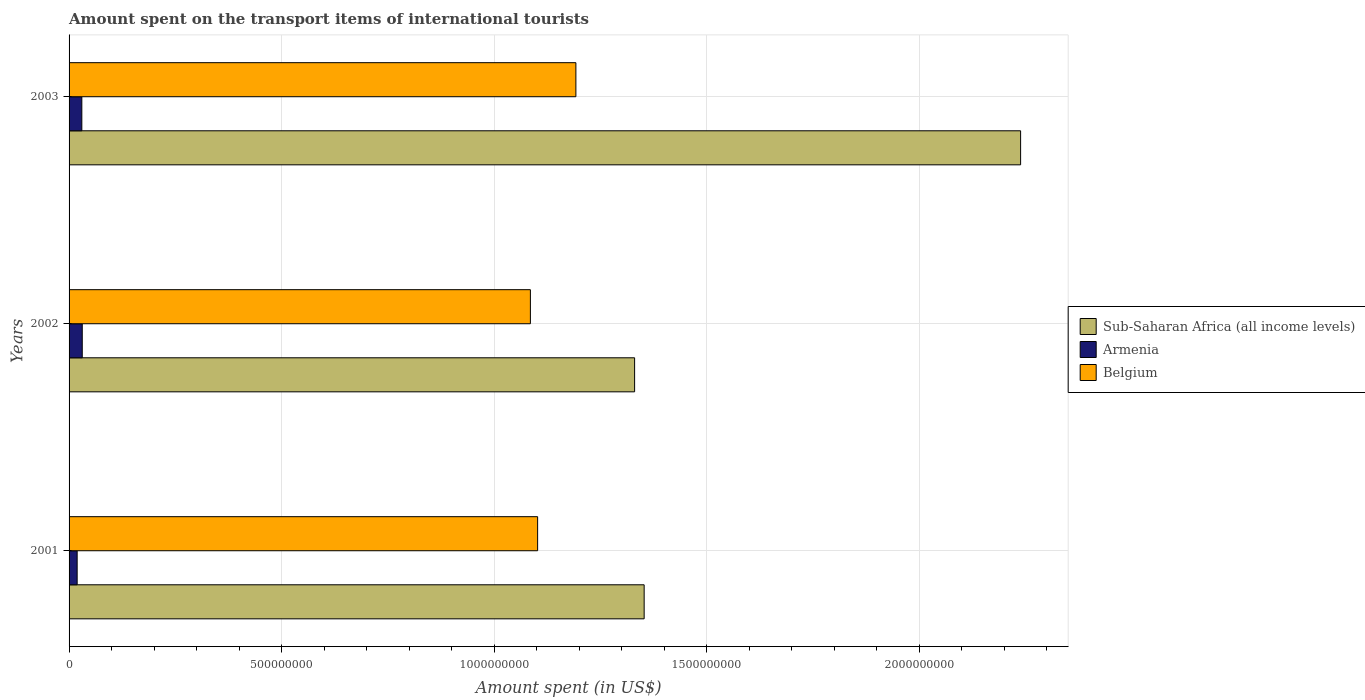How many groups of bars are there?
Make the answer very short. 3. Are the number of bars on each tick of the Y-axis equal?
Provide a short and direct response. Yes. How many bars are there on the 3rd tick from the top?
Your answer should be very brief. 3. In how many cases, is the number of bars for a given year not equal to the number of legend labels?
Give a very brief answer. 0. What is the amount spent on the transport items of international tourists in Sub-Saharan Africa (all income levels) in 2002?
Keep it short and to the point. 1.33e+09. Across all years, what is the maximum amount spent on the transport items of international tourists in Belgium?
Your response must be concise. 1.19e+09. Across all years, what is the minimum amount spent on the transport items of international tourists in Belgium?
Give a very brief answer. 1.08e+09. In which year was the amount spent on the transport items of international tourists in Sub-Saharan Africa (all income levels) minimum?
Give a very brief answer. 2002. What is the total amount spent on the transport items of international tourists in Sub-Saharan Africa (all income levels) in the graph?
Keep it short and to the point. 4.92e+09. What is the difference between the amount spent on the transport items of international tourists in Sub-Saharan Africa (all income levels) in 2001 and that in 2002?
Keep it short and to the point. 2.24e+07. What is the difference between the amount spent on the transport items of international tourists in Armenia in 2001 and the amount spent on the transport items of international tourists in Belgium in 2003?
Provide a short and direct response. -1.17e+09. What is the average amount spent on the transport items of international tourists in Sub-Saharan Africa (all income levels) per year?
Your answer should be very brief. 1.64e+09. In the year 2001, what is the difference between the amount spent on the transport items of international tourists in Sub-Saharan Africa (all income levels) and amount spent on the transport items of international tourists in Armenia?
Give a very brief answer. 1.33e+09. In how many years, is the amount spent on the transport items of international tourists in Sub-Saharan Africa (all income levels) greater than 1500000000 US$?
Offer a very short reply. 1. What is the ratio of the amount spent on the transport items of international tourists in Sub-Saharan Africa (all income levels) in 2001 to that in 2003?
Your response must be concise. 0.6. What is the difference between the highest and the second highest amount spent on the transport items of international tourists in Armenia?
Make the answer very short. 1.00e+06. What is the difference between the highest and the lowest amount spent on the transport items of international tourists in Sub-Saharan Africa (all income levels)?
Offer a very short reply. 9.08e+08. Is the sum of the amount spent on the transport items of international tourists in Armenia in 2001 and 2003 greater than the maximum amount spent on the transport items of international tourists in Sub-Saharan Africa (all income levels) across all years?
Make the answer very short. No. What does the 3rd bar from the top in 2003 represents?
Your response must be concise. Sub-Saharan Africa (all income levels). What does the 3rd bar from the bottom in 2002 represents?
Offer a very short reply. Belgium. Are all the bars in the graph horizontal?
Ensure brevity in your answer.  Yes. How many years are there in the graph?
Your response must be concise. 3. Does the graph contain grids?
Your answer should be very brief. Yes. How many legend labels are there?
Provide a short and direct response. 3. How are the legend labels stacked?
Provide a succinct answer. Vertical. What is the title of the graph?
Your response must be concise. Amount spent on the transport items of international tourists. Does "Estonia" appear as one of the legend labels in the graph?
Offer a terse response. No. What is the label or title of the X-axis?
Give a very brief answer. Amount spent (in US$). What is the label or title of the Y-axis?
Your answer should be compact. Years. What is the Amount spent (in US$) in Sub-Saharan Africa (all income levels) in 2001?
Provide a short and direct response. 1.35e+09. What is the Amount spent (in US$) in Armenia in 2001?
Keep it short and to the point. 1.90e+07. What is the Amount spent (in US$) of Belgium in 2001?
Offer a terse response. 1.10e+09. What is the Amount spent (in US$) in Sub-Saharan Africa (all income levels) in 2002?
Your answer should be very brief. 1.33e+09. What is the Amount spent (in US$) of Armenia in 2002?
Offer a very short reply. 3.10e+07. What is the Amount spent (in US$) in Belgium in 2002?
Make the answer very short. 1.08e+09. What is the Amount spent (in US$) in Sub-Saharan Africa (all income levels) in 2003?
Make the answer very short. 2.24e+09. What is the Amount spent (in US$) in Armenia in 2003?
Your answer should be compact. 3.00e+07. What is the Amount spent (in US$) in Belgium in 2003?
Your response must be concise. 1.19e+09. Across all years, what is the maximum Amount spent (in US$) of Sub-Saharan Africa (all income levels)?
Offer a very short reply. 2.24e+09. Across all years, what is the maximum Amount spent (in US$) in Armenia?
Ensure brevity in your answer.  3.10e+07. Across all years, what is the maximum Amount spent (in US$) in Belgium?
Your response must be concise. 1.19e+09. Across all years, what is the minimum Amount spent (in US$) in Sub-Saharan Africa (all income levels)?
Keep it short and to the point. 1.33e+09. Across all years, what is the minimum Amount spent (in US$) of Armenia?
Offer a terse response. 1.90e+07. Across all years, what is the minimum Amount spent (in US$) in Belgium?
Offer a very short reply. 1.08e+09. What is the total Amount spent (in US$) in Sub-Saharan Africa (all income levels) in the graph?
Your answer should be compact. 4.92e+09. What is the total Amount spent (in US$) in Armenia in the graph?
Your answer should be very brief. 8.00e+07. What is the total Amount spent (in US$) in Belgium in the graph?
Provide a succinct answer. 3.38e+09. What is the difference between the Amount spent (in US$) of Sub-Saharan Africa (all income levels) in 2001 and that in 2002?
Offer a terse response. 2.24e+07. What is the difference between the Amount spent (in US$) in Armenia in 2001 and that in 2002?
Your response must be concise. -1.20e+07. What is the difference between the Amount spent (in US$) of Belgium in 2001 and that in 2002?
Provide a succinct answer. 1.70e+07. What is the difference between the Amount spent (in US$) of Sub-Saharan Africa (all income levels) in 2001 and that in 2003?
Keep it short and to the point. -8.85e+08. What is the difference between the Amount spent (in US$) of Armenia in 2001 and that in 2003?
Provide a short and direct response. -1.10e+07. What is the difference between the Amount spent (in US$) in Belgium in 2001 and that in 2003?
Provide a short and direct response. -9.00e+07. What is the difference between the Amount spent (in US$) in Sub-Saharan Africa (all income levels) in 2002 and that in 2003?
Offer a very short reply. -9.08e+08. What is the difference between the Amount spent (in US$) in Armenia in 2002 and that in 2003?
Offer a very short reply. 1.00e+06. What is the difference between the Amount spent (in US$) of Belgium in 2002 and that in 2003?
Your response must be concise. -1.07e+08. What is the difference between the Amount spent (in US$) in Sub-Saharan Africa (all income levels) in 2001 and the Amount spent (in US$) in Armenia in 2002?
Ensure brevity in your answer.  1.32e+09. What is the difference between the Amount spent (in US$) in Sub-Saharan Africa (all income levels) in 2001 and the Amount spent (in US$) in Belgium in 2002?
Provide a short and direct response. 2.68e+08. What is the difference between the Amount spent (in US$) in Armenia in 2001 and the Amount spent (in US$) in Belgium in 2002?
Your answer should be compact. -1.07e+09. What is the difference between the Amount spent (in US$) in Sub-Saharan Africa (all income levels) in 2001 and the Amount spent (in US$) in Armenia in 2003?
Provide a short and direct response. 1.32e+09. What is the difference between the Amount spent (in US$) of Sub-Saharan Africa (all income levels) in 2001 and the Amount spent (in US$) of Belgium in 2003?
Keep it short and to the point. 1.61e+08. What is the difference between the Amount spent (in US$) of Armenia in 2001 and the Amount spent (in US$) of Belgium in 2003?
Offer a very short reply. -1.17e+09. What is the difference between the Amount spent (in US$) in Sub-Saharan Africa (all income levels) in 2002 and the Amount spent (in US$) in Armenia in 2003?
Provide a succinct answer. 1.30e+09. What is the difference between the Amount spent (in US$) of Sub-Saharan Africa (all income levels) in 2002 and the Amount spent (in US$) of Belgium in 2003?
Keep it short and to the point. 1.38e+08. What is the difference between the Amount spent (in US$) of Armenia in 2002 and the Amount spent (in US$) of Belgium in 2003?
Provide a short and direct response. -1.16e+09. What is the average Amount spent (in US$) of Sub-Saharan Africa (all income levels) per year?
Keep it short and to the point. 1.64e+09. What is the average Amount spent (in US$) of Armenia per year?
Provide a short and direct response. 2.67e+07. What is the average Amount spent (in US$) in Belgium per year?
Provide a succinct answer. 1.13e+09. In the year 2001, what is the difference between the Amount spent (in US$) in Sub-Saharan Africa (all income levels) and Amount spent (in US$) in Armenia?
Give a very brief answer. 1.33e+09. In the year 2001, what is the difference between the Amount spent (in US$) of Sub-Saharan Africa (all income levels) and Amount spent (in US$) of Belgium?
Offer a terse response. 2.51e+08. In the year 2001, what is the difference between the Amount spent (in US$) of Armenia and Amount spent (in US$) of Belgium?
Keep it short and to the point. -1.08e+09. In the year 2002, what is the difference between the Amount spent (in US$) of Sub-Saharan Africa (all income levels) and Amount spent (in US$) of Armenia?
Offer a very short reply. 1.30e+09. In the year 2002, what is the difference between the Amount spent (in US$) in Sub-Saharan Africa (all income levels) and Amount spent (in US$) in Belgium?
Your answer should be compact. 2.45e+08. In the year 2002, what is the difference between the Amount spent (in US$) of Armenia and Amount spent (in US$) of Belgium?
Give a very brief answer. -1.05e+09. In the year 2003, what is the difference between the Amount spent (in US$) of Sub-Saharan Africa (all income levels) and Amount spent (in US$) of Armenia?
Your response must be concise. 2.21e+09. In the year 2003, what is the difference between the Amount spent (in US$) of Sub-Saharan Africa (all income levels) and Amount spent (in US$) of Belgium?
Offer a very short reply. 1.05e+09. In the year 2003, what is the difference between the Amount spent (in US$) in Armenia and Amount spent (in US$) in Belgium?
Your answer should be compact. -1.16e+09. What is the ratio of the Amount spent (in US$) of Sub-Saharan Africa (all income levels) in 2001 to that in 2002?
Your response must be concise. 1.02. What is the ratio of the Amount spent (in US$) of Armenia in 2001 to that in 2002?
Ensure brevity in your answer.  0.61. What is the ratio of the Amount spent (in US$) in Belgium in 2001 to that in 2002?
Provide a short and direct response. 1.02. What is the ratio of the Amount spent (in US$) of Sub-Saharan Africa (all income levels) in 2001 to that in 2003?
Keep it short and to the point. 0.6. What is the ratio of the Amount spent (in US$) of Armenia in 2001 to that in 2003?
Your response must be concise. 0.63. What is the ratio of the Amount spent (in US$) of Belgium in 2001 to that in 2003?
Give a very brief answer. 0.92. What is the ratio of the Amount spent (in US$) in Sub-Saharan Africa (all income levels) in 2002 to that in 2003?
Offer a terse response. 0.59. What is the ratio of the Amount spent (in US$) of Belgium in 2002 to that in 2003?
Offer a terse response. 0.91. What is the difference between the highest and the second highest Amount spent (in US$) of Sub-Saharan Africa (all income levels)?
Give a very brief answer. 8.85e+08. What is the difference between the highest and the second highest Amount spent (in US$) in Armenia?
Ensure brevity in your answer.  1.00e+06. What is the difference between the highest and the second highest Amount spent (in US$) of Belgium?
Make the answer very short. 9.00e+07. What is the difference between the highest and the lowest Amount spent (in US$) of Sub-Saharan Africa (all income levels)?
Make the answer very short. 9.08e+08. What is the difference between the highest and the lowest Amount spent (in US$) of Armenia?
Your answer should be compact. 1.20e+07. What is the difference between the highest and the lowest Amount spent (in US$) of Belgium?
Ensure brevity in your answer.  1.07e+08. 